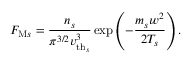<formula> <loc_0><loc_0><loc_500><loc_500>F _ { M s } = \frac { n _ { s } } { \pi ^ { 3 / 2 } { v _ { t h _ { s } } } ^ { 3 } } \exp \left ( - \frac { m _ { s } w ^ { 2 } } { 2 T _ { s } } \right ) .</formula> 